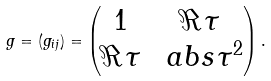Convert formula to latex. <formula><loc_0><loc_0><loc_500><loc_500>g = ( g _ { i j } ) = \begin{pmatrix} 1 & \Re \tau \\ \Re \tau & \ a b s { \tau } ^ { 2 } \end{pmatrix} .</formula> 